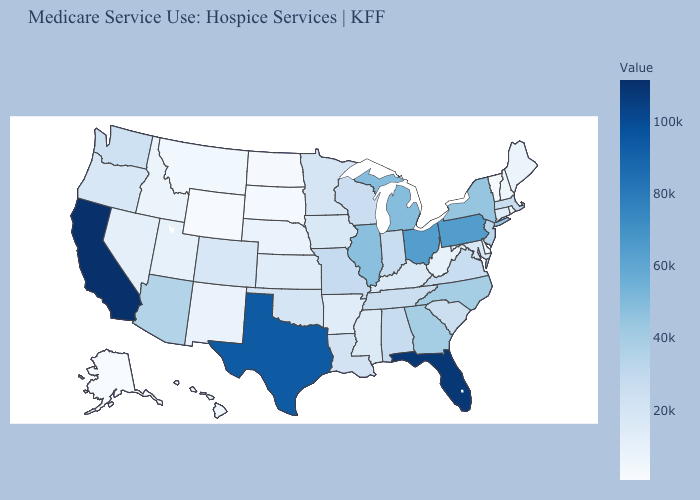Among the states that border Oklahoma , does Kansas have the highest value?
Keep it brief. No. Among the states that border Connecticut , which have the highest value?
Short answer required. New York. 